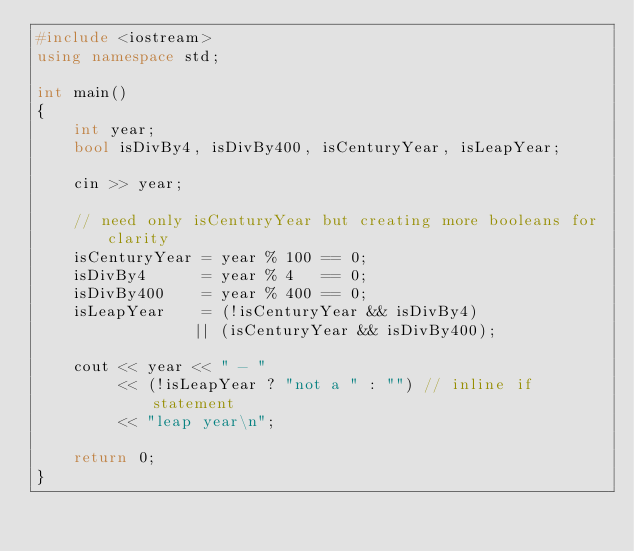<code> <loc_0><loc_0><loc_500><loc_500><_C++_>#include <iostream>
using namespace std;

int main()
{
    int year;
    bool isDivBy4, isDivBy400, isCenturyYear, isLeapYear;

    cin >> year;

    // need only isCenturyYear but creating more booleans for clarity
    isCenturyYear = year % 100 == 0;
    isDivBy4      = year % 4   == 0;
    isDivBy400    = year % 400 == 0;
    isLeapYear    = (!isCenturyYear && isDivBy4)
                 || (isCenturyYear && isDivBy400);

    cout << year << " - "
         << (!isLeapYear ? "not a " : "") // inline if statement
         << "leap year\n";

    return 0;
}</code> 